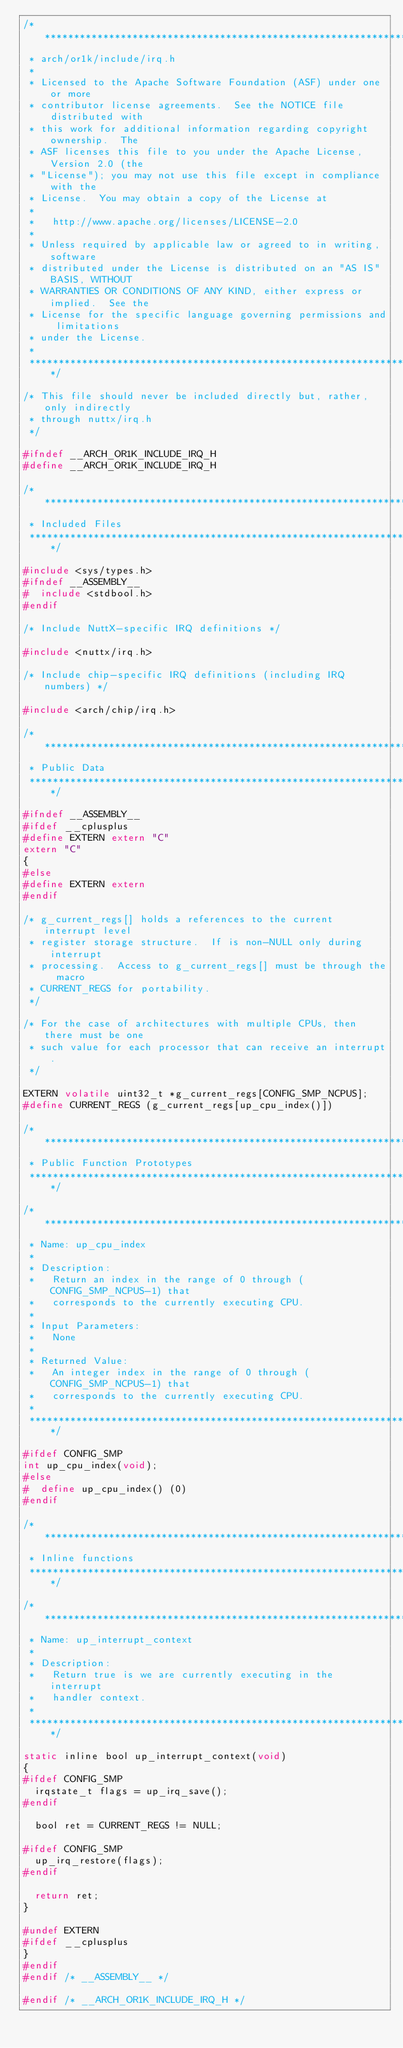Convert code to text. <code><loc_0><loc_0><loc_500><loc_500><_C_>/****************************************************************************
 * arch/or1k/include/irq.h
 *
 * Licensed to the Apache Software Foundation (ASF) under one or more
 * contributor license agreements.  See the NOTICE file distributed with
 * this work for additional information regarding copyright ownership.  The
 * ASF licenses this file to you under the Apache License, Version 2.0 (the
 * "License"); you may not use this file except in compliance with the
 * License.  You may obtain a copy of the License at
 *
 *   http://www.apache.org/licenses/LICENSE-2.0
 *
 * Unless required by applicable law or agreed to in writing, software
 * distributed under the License is distributed on an "AS IS" BASIS, WITHOUT
 * WARRANTIES OR CONDITIONS OF ANY KIND, either express or implied.  See the
 * License for the specific language governing permissions and limitations
 * under the License.
 *
 ****************************************************************************/

/* This file should never be included directly but, rather, only indirectly
 * through nuttx/irq.h
 */

#ifndef __ARCH_OR1K_INCLUDE_IRQ_H
#define __ARCH_OR1K_INCLUDE_IRQ_H

/****************************************************************************
 * Included Files
 ****************************************************************************/

#include <sys/types.h>
#ifndef __ASSEMBLY__
#  include <stdbool.h>
#endif

/* Include NuttX-specific IRQ definitions */

#include <nuttx/irq.h>

/* Include chip-specific IRQ definitions (including IRQ numbers) */

#include <arch/chip/irq.h>

/****************************************************************************
 * Public Data
 ****************************************************************************/

#ifndef __ASSEMBLY__
#ifdef __cplusplus
#define EXTERN extern "C"
extern "C"
{
#else
#define EXTERN extern
#endif

/* g_current_regs[] holds a references to the current interrupt level
 * register storage structure.  If is non-NULL only during interrupt
 * processing.  Access to g_current_regs[] must be through the macro
 * CURRENT_REGS for portability.
 */

/* For the case of architectures with multiple CPUs, then there must be one
 * such value for each processor that can receive an interrupt.
 */

EXTERN volatile uint32_t *g_current_regs[CONFIG_SMP_NCPUS];
#define CURRENT_REGS (g_current_regs[up_cpu_index()])

/****************************************************************************
 * Public Function Prototypes
 ****************************************************************************/

/****************************************************************************
 * Name: up_cpu_index
 *
 * Description:
 *   Return an index in the range of 0 through (CONFIG_SMP_NCPUS-1) that
 *   corresponds to the currently executing CPU.
 *
 * Input Parameters:
 *   None
 *
 * Returned Value:
 *   An integer index in the range of 0 through (CONFIG_SMP_NCPUS-1) that
 *   corresponds to the currently executing CPU.
 *
 ****************************************************************************/

#ifdef CONFIG_SMP
int up_cpu_index(void);
#else
#  define up_cpu_index() (0)
#endif

/****************************************************************************
 * Inline functions
 ****************************************************************************/

/****************************************************************************
 * Name: up_interrupt_context
 *
 * Description:
 *   Return true is we are currently executing in the interrupt
 *   handler context.
 *
 ****************************************************************************/

static inline bool up_interrupt_context(void)
{
#ifdef CONFIG_SMP
  irqstate_t flags = up_irq_save();
#endif

  bool ret = CURRENT_REGS != NULL;

#ifdef CONFIG_SMP
  up_irq_restore(flags);
#endif

  return ret;
}

#undef EXTERN
#ifdef __cplusplus
}
#endif
#endif /* __ASSEMBLY__ */

#endif /* __ARCH_OR1K_INCLUDE_IRQ_H */
</code> 